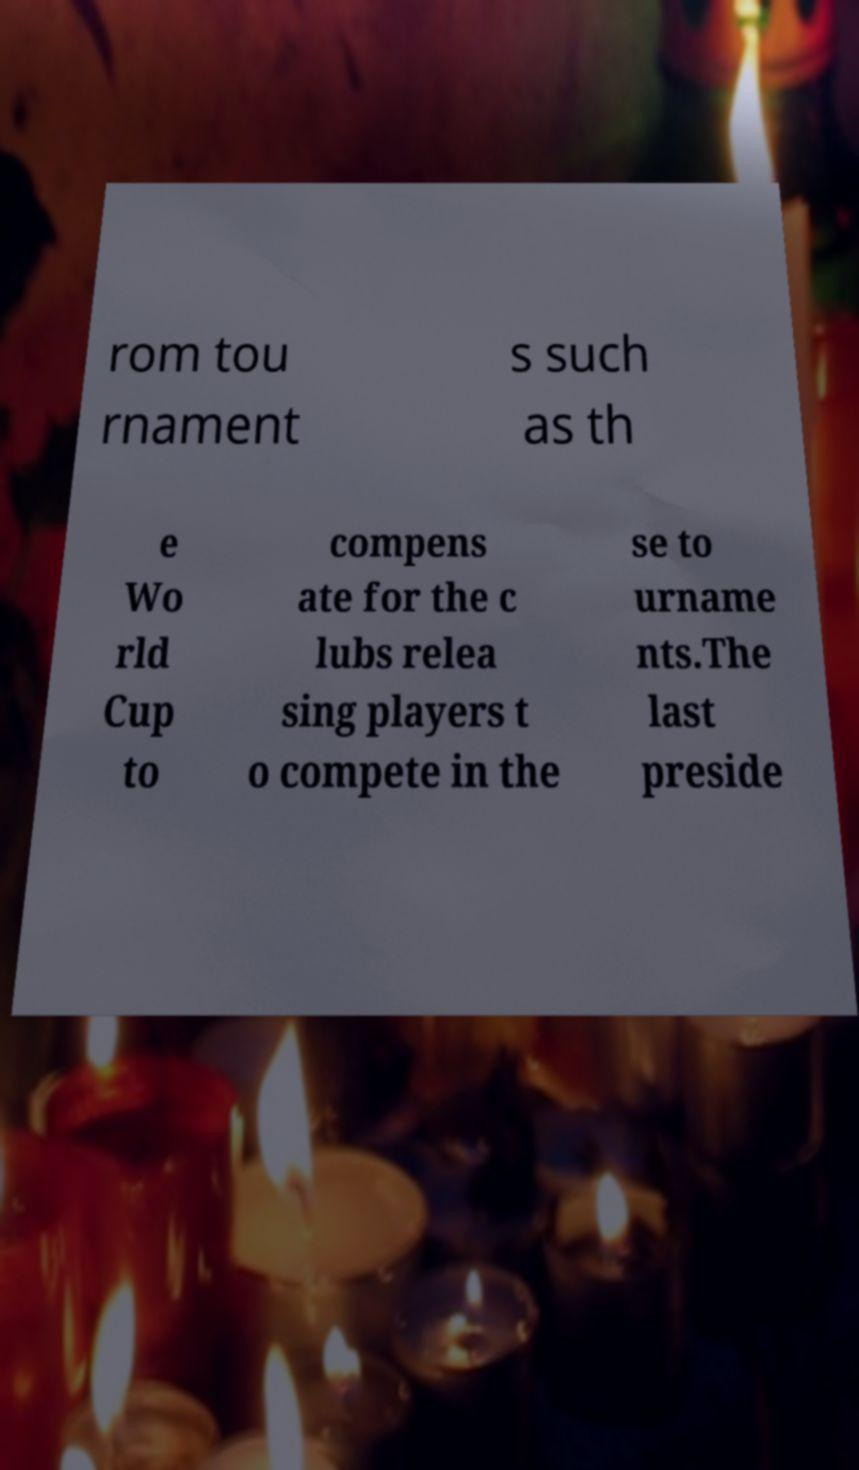I need the written content from this picture converted into text. Can you do that? rom tou rnament s such as th e Wo rld Cup to compens ate for the c lubs relea sing players t o compete in the se to urname nts.The last preside 